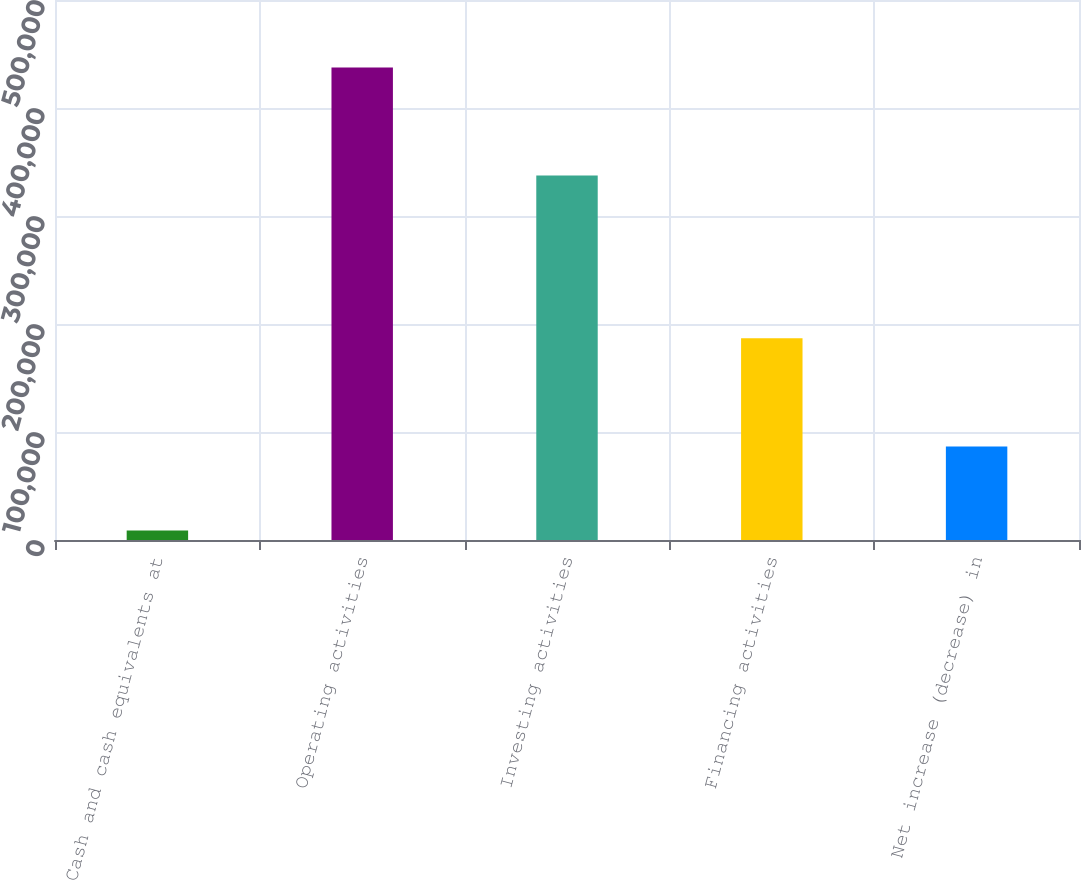Convert chart. <chart><loc_0><loc_0><loc_500><loc_500><bar_chart><fcel>Cash and cash equivalents at<fcel>Operating activities<fcel>Investing activities<fcel>Financing activities<fcel>Net increase (decrease) in<nl><fcel>8834<fcel>437520<fcel>337509<fcel>186690<fcel>86679<nl></chart> 